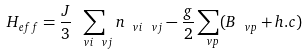Convert formula to latex. <formula><loc_0><loc_0><loc_500><loc_500>H _ { e f f } = \frac { J } { 3 } \sum _ { \ v i \ v j } n _ { \ v i \ v j } - \frac { g } { 2 } \sum _ { \ v p } ( B _ { \ v p } + h . c ) \\</formula> 